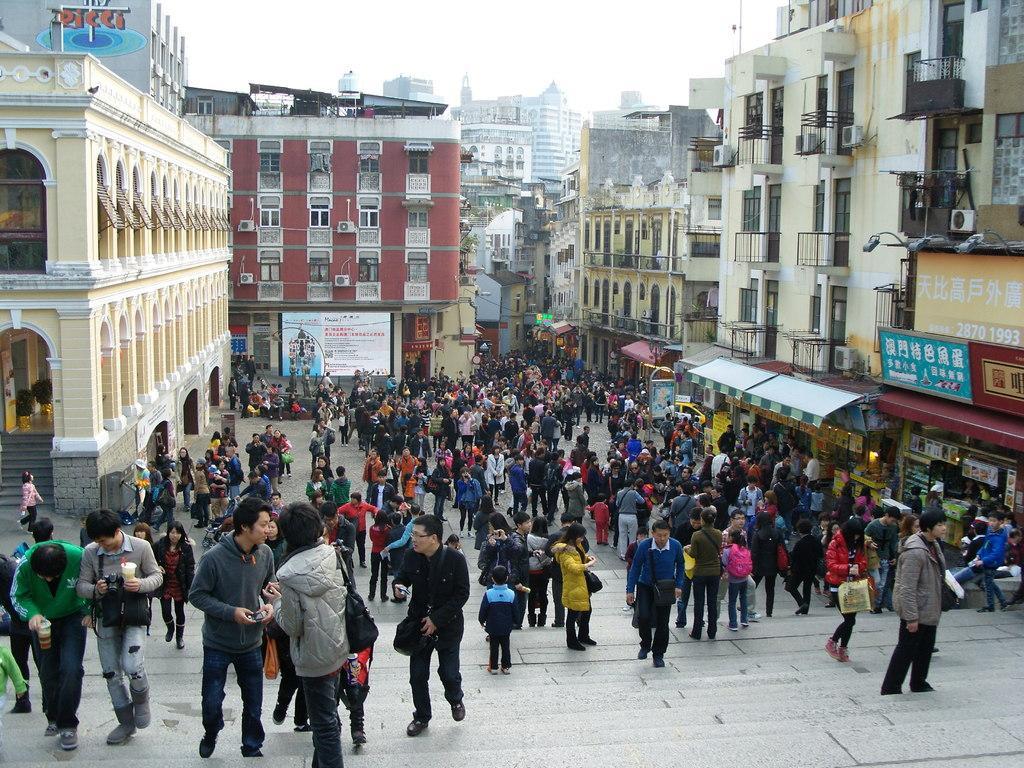Please provide a concise description of this image. This is the picture of a city. In this image there are group of people, few are standing and few are walking. At the back there are buildings and there are hoardings on the buildings. At the top there is sky. At the bottom there is a road and staircase. 